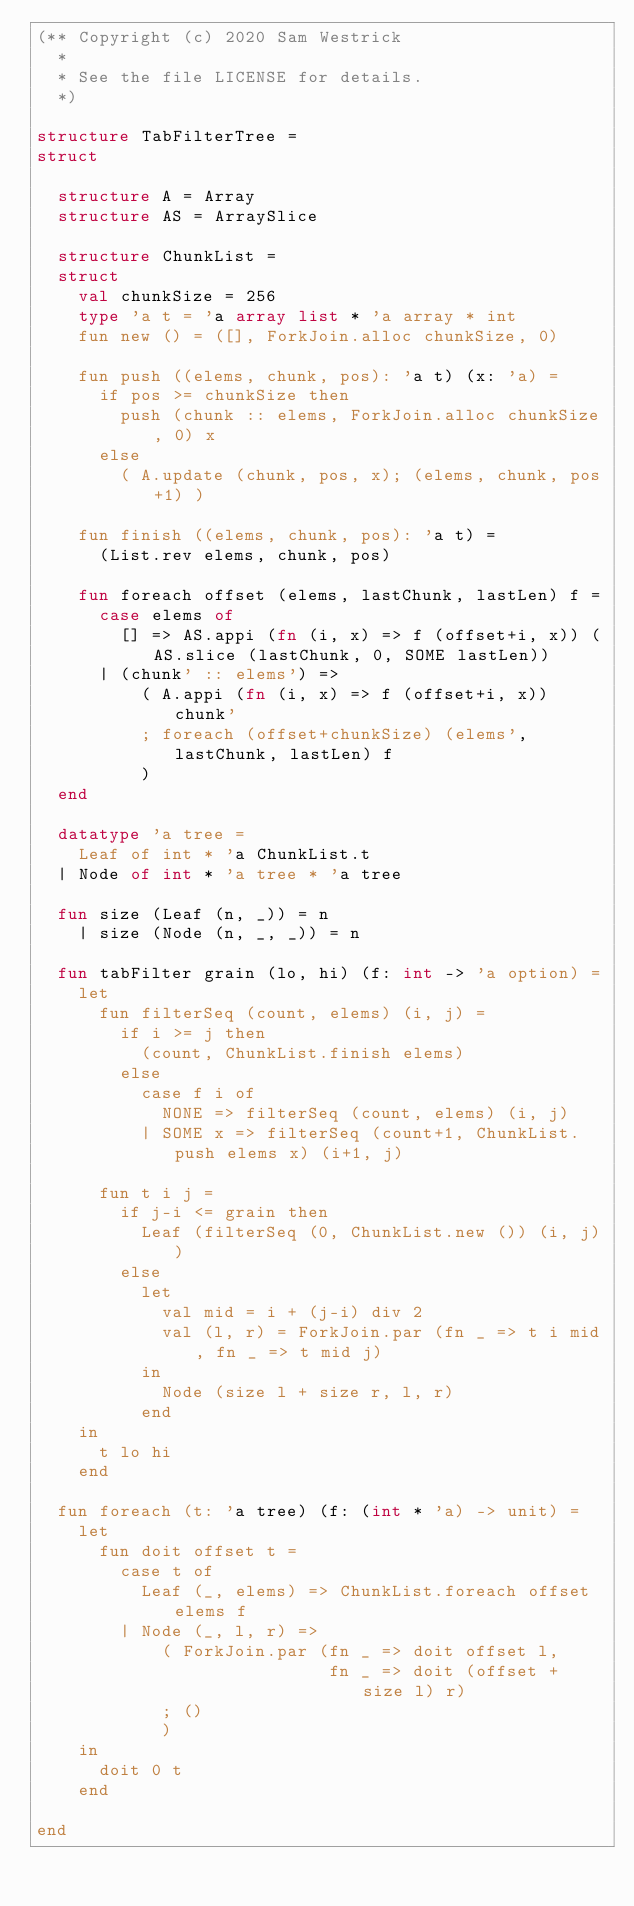Convert code to text. <code><loc_0><loc_0><loc_500><loc_500><_SML_>(** Copyright (c) 2020 Sam Westrick
  *
  * See the file LICENSE for details.
  *)

structure TabFilterTree =
struct

  structure A = Array
  structure AS = ArraySlice

  structure ChunkList =
  struct
    val chunkSize = 256
    type 'a t = 'a array list * 'a array * int
    fun new () = ([], ForkJoin.alloc chunkSize, 0)

    fun push ((elems, chunk, pos): 'a t) (x: 'a) =
      if pos >= chunkSize then
        push (chunk :: elems, ForkJoin.alloc chunkSize, 0) x
      else
        ( A.update (chunk, pos, x); (elems, chunk, pos+1) )

    fun finish ((elems, chunk, pos): 'a t) =
      (List.rev elems, chunk, pos)

    fun foreach offset (elems, lastChunk, lastLen) f =
      case elems of
        [] => AS.appi (fn (i, x) => f (offset+i, x)) (AS.slice (lastChunk, 0, SOME lastLen))
      | (chunk' :: elems') =>
          ( A.appi (fn (i, x) => f (offset+i, x)) chunk'
          ; foreach (offset+chunkSize) (elems', lastChunk, lastLen) f
          )
  end

  datatype 'a tree =
    Leaf of int * 'a ChunkList.t
  | Node of int * 'a tree * 'a tree

  fun size (Leaf (n, _)) = n
    | size (Node (n, _, _)) = n

  fun tabFilter grain (lo, hi) (f: int -> 'a option) =
    let
      fun filterSeq (count, elems) (i, j) =
        if i >= j then
          (count, ChunkList.finish elems)
        else
          case f i of
            NONE => filterSeq (count, elems) (i, j)
          | SOME x => filterSeq (count+1, ChunkList.push elems x) (i+1, j)

      fun t i j =
        if j-i <= grain then
          Leaf (filterSeq (0, ChunkList.new ()) (i, j))
        else
          let
            val mid = i + (j-i) div 2
            val (l, r) = ForkJoin.par (fn _ => t i mid, fn _ => t mid j)
          in
            Node (size l + size r, l, r)
          end
    in
      t lo hi
    end

  fun foreach (t: 'a tree) (f: (int * 'a) -> unit) =
    let
      fun doit offset t =
        case t of
          Leaf (_, elems) => ChunkList.foreach offset elems f
        | Node (_, l, r) =>
            ( ForkJoin.par (fn _ => doit offset l,
                            fn _ => doit (offset + size l) r)
            ; ()
            )
    in
      doit 0 t
    end

end
</code> 